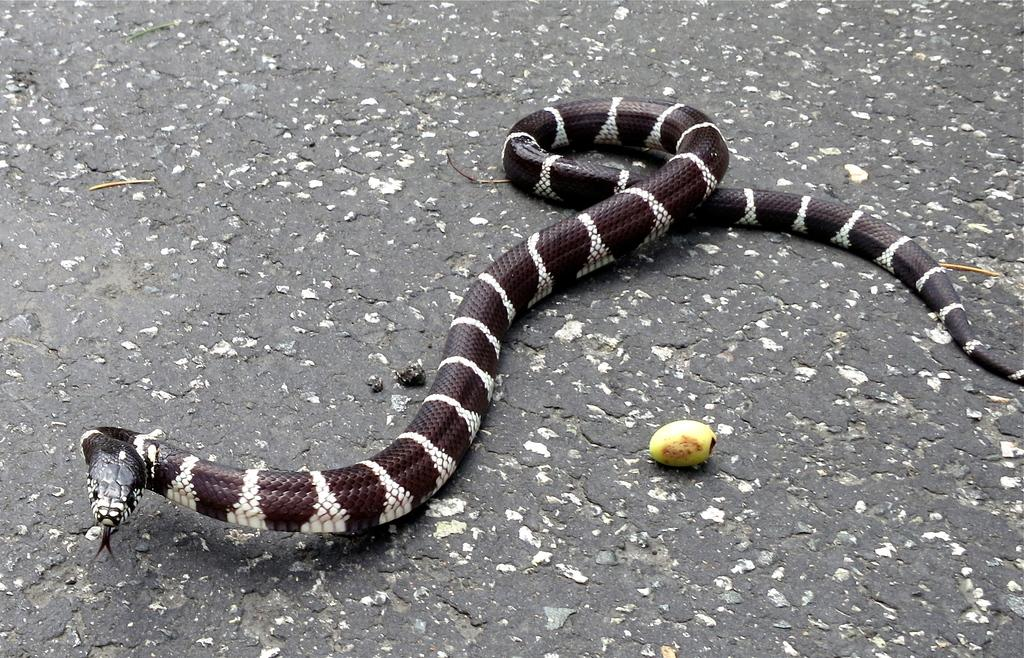What type of animal is on the floor in the image? There is a snake on the floor in the image. What is located in the front of the image? There is a fruit in the front of the image. What substance is the snake using to break the record in the image? There is no record or substance related to the snake in the image; it is simply a snake on the floor. 